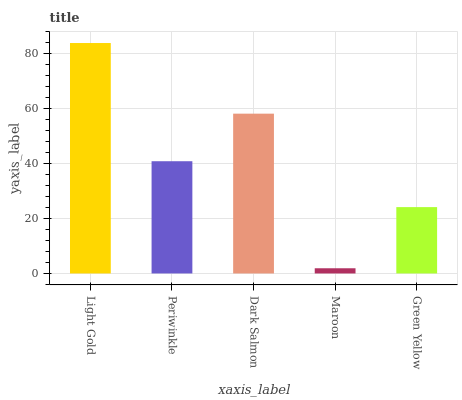Is Periwinkle the minimum?
Answer yes or no. No. Is Periwinkle the maximum?
Answer yes or no. No. Is Light Gold greater than Periwinkle?
Answer yes or no. Yes. Is Periwinkle less than Light Gold?
Answer yes or no. Yes. Is Periwinkle greater than Light Gold?
Answer yes or no. No. Is Light Gold less than Periwinkle?
Answer yes or no. No. Is Periwinkle the high median?
Answer yes or no. Yes. Is Periwinkle the low median?
Answer yes or no. Yes. Is Green Yellow the high median?
Answer yes or no. No. Is Light Gold the low median?
Answer yes or no. No. 